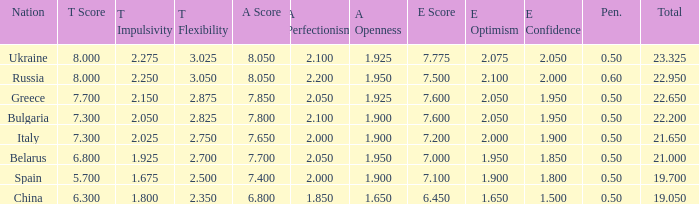What E score has the T score of 8 and a number smaller than 22.95? None. Could you parse the entire table as a dict? {'header': ['Nation', 'T Score', 'T Impulsivity', 'T Flexibility', 'A Score', 'A Perfectionism', 'A Openness', 'E Score', 'E Optimism', 'E Confidence', 'Pen.', 'Total'], 'rows': [['Ukraine', '8.000', '2.275', '3.025', '8.050', '2.100', '1.925', '7.775', '2.075', '2.050', '0.50', '23.325'], ['Russia', '8.000', '2.250', '3.050', '8.050', '2.200', '1.950', '7.500', '2.100', '2.000', '0.60', '22.950'], ['Greece', '7.700', '2.150', '2.875', '7.850', '2.050', '1.925', '7.600', '2.050', '1.950', '0.50', '22.650'], ['Bulgaria', '7.300', '2.050', '2.825', '7.800', '2.100', '1.900', '7.600', '2.050', '1.950', '0.50', '22.200'], ['Italy', '7.300', '2.025', '2.750', '7.650', '2.000', '1.900', '7.200', '2.000', '1.900', '0.50', '21.650'], ['Belarus', '6.800', '1.925', '2.700', '7.700', '2.050', '1.950', '7.000', '1.950', '1.850', '0.50', '21.000'], ['Spain', '5.700', '1.675', '2.500', '7.400', '2.000', '1.900', '7.100', '1.900', '1.800', '0.50', '19.700'], ['China', '6.300', '1.800', '2.350', '6.800', '1.850', '1.650', '6.450', '1.650', '1.500', '0.50', '19.050']]} 